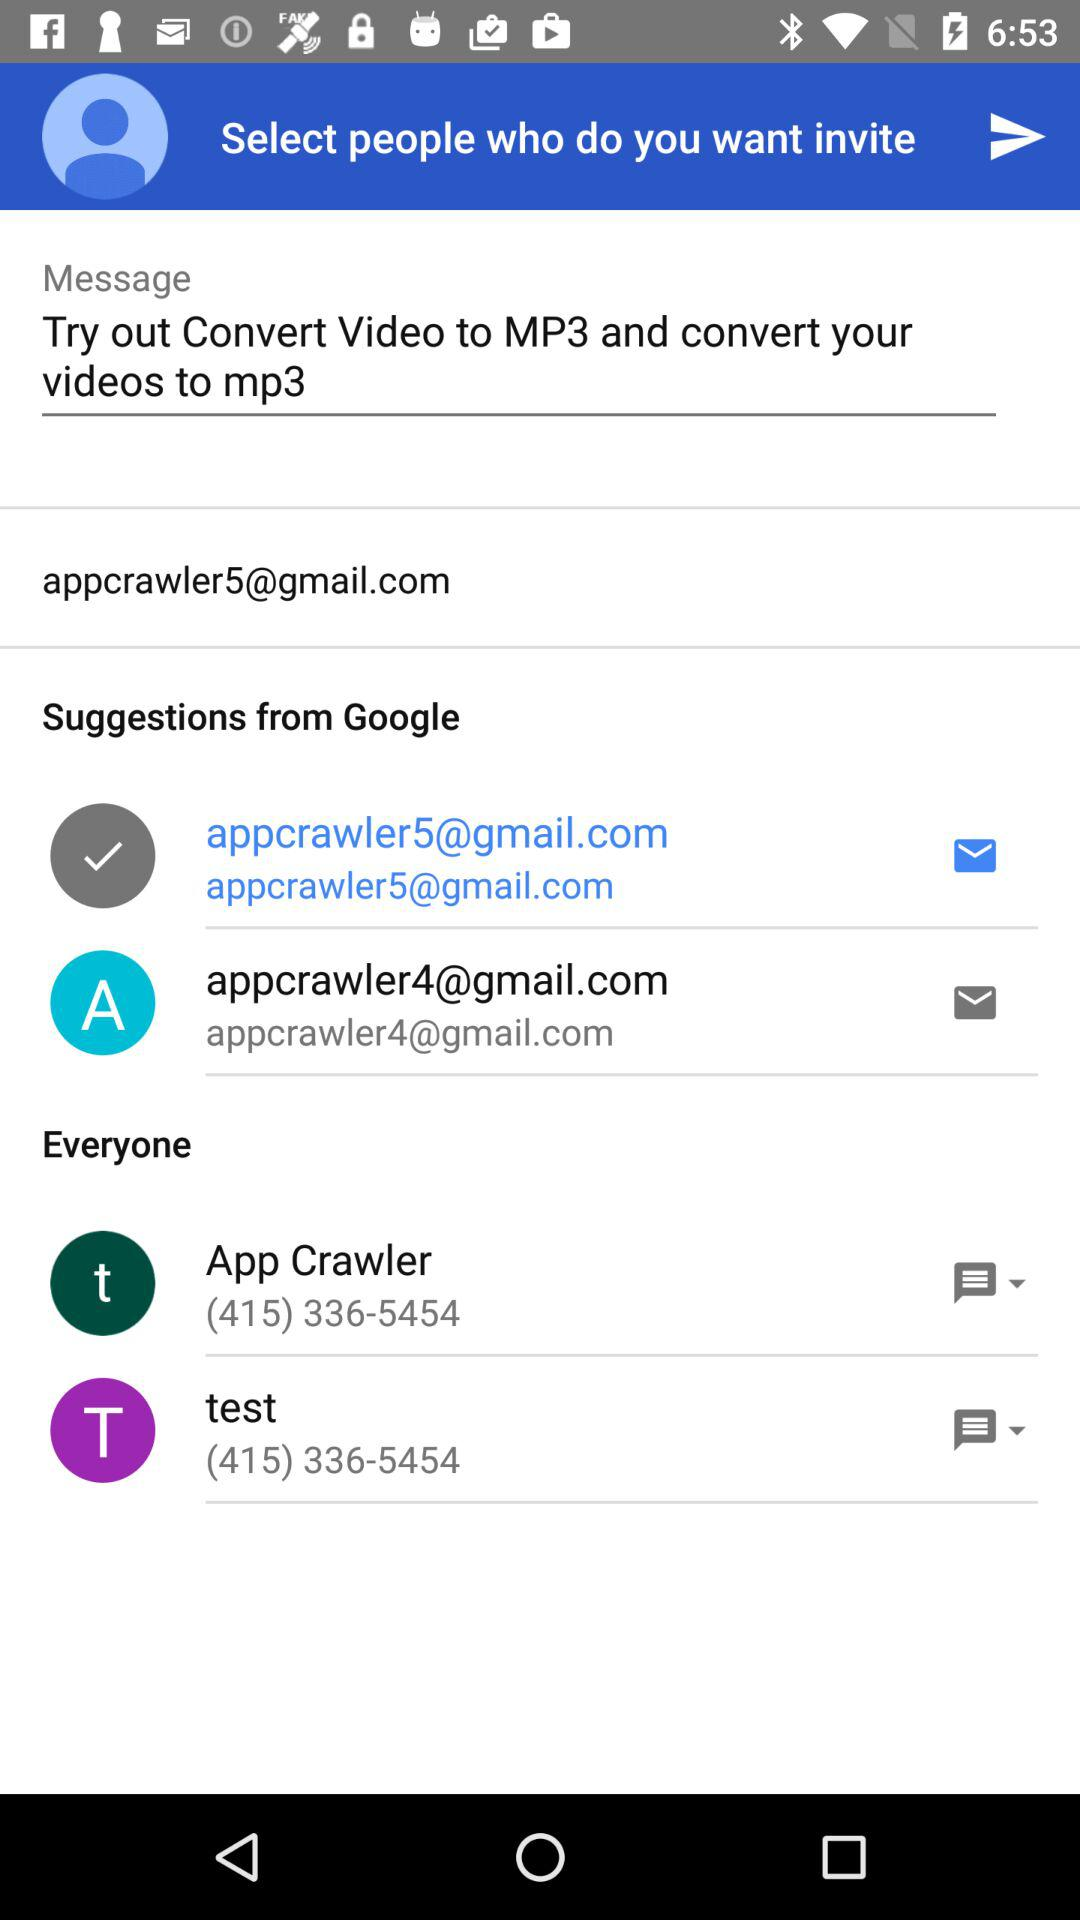Which is the selected email address? The selected email address is appcrawler5@gmail.com. 